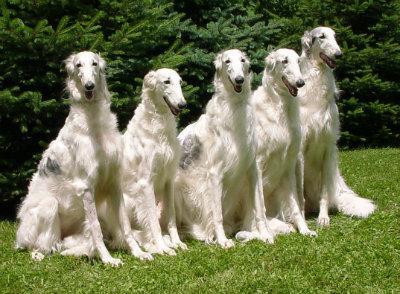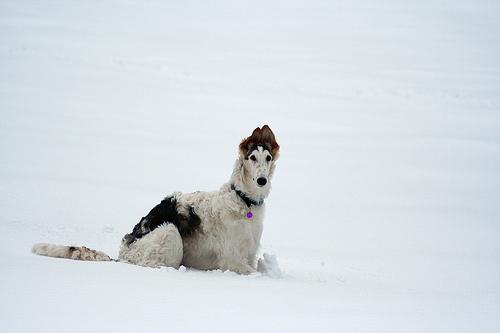The first image is the image on the left, the second image is the image on the right. Analyze the images presented: Is the assertion "A single large dog is standing upright in each image." valid? Answer yes or no. No. The first image is the image on the left, the second image is the image on the right. Evaluate the accuracy of this statement regarding the images: "All images show one hound standing in profile on grass.". Is it true? Answer yes or no. No. 